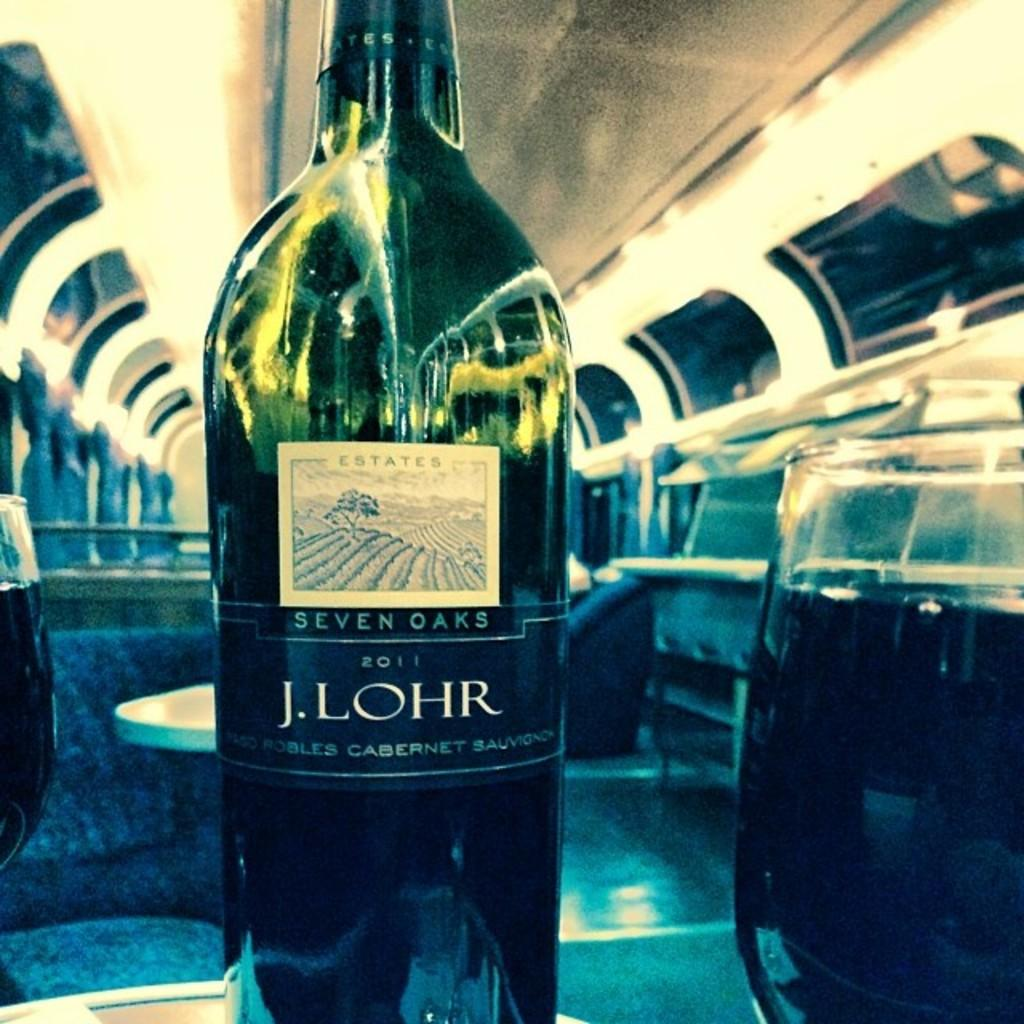What is present in the image that can hold a liquid? There is a bottle in the image that can hold a liquid. How many containers for drinking are visible in the image? There are two glasses in the image. What type of furniture can be seen in the background of the image? There is a table in the background of the image. What type of clock is hanging on the wall in the image? There is no clock present in the image. What type of suit is the person wearing in the image? There is no person or suit present in the image. 